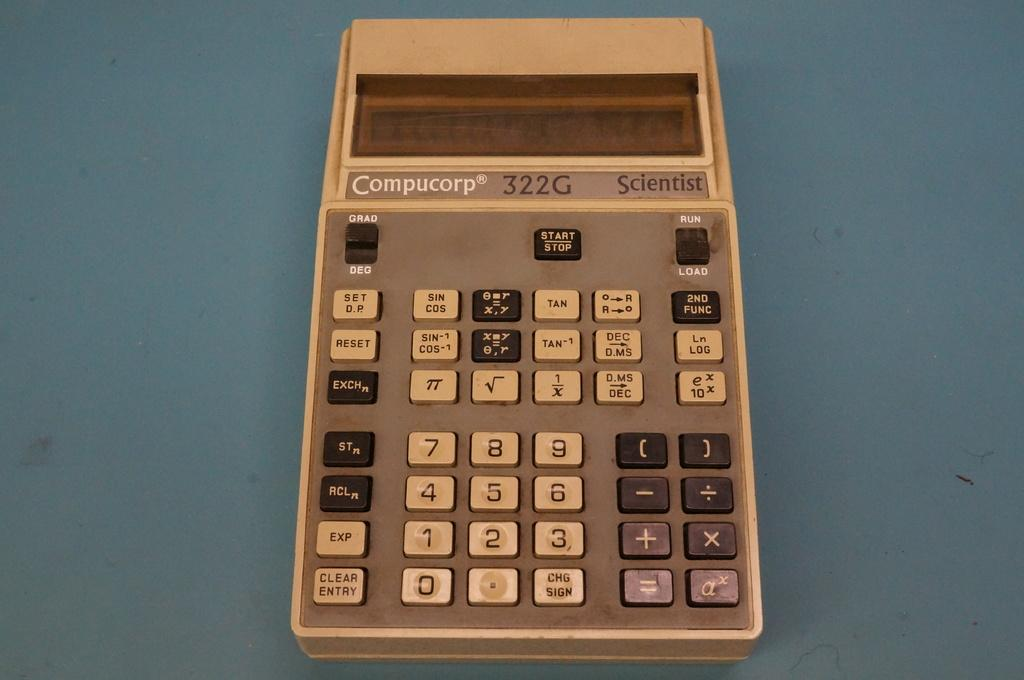<image>
Give a short and clear explanation of the subsequent image. An oldstyle calculator compucorp sits on a table. 